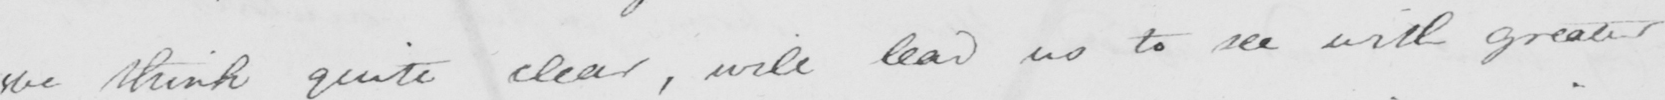Can you read and transcribe this handwriting? we think quite clear , will lead us to see with greater 